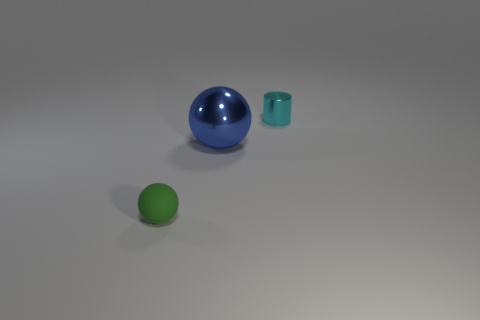Is there any other thing that is the same size as the cyan thing?
Provide a succinct answer. Yes. There is a metal object in front of the tiny cyan shiny thing; is it the same shape as the small metallic thing?
Ensure brevity in your answer.  No. Are there more tiny matte objects that are in front of the metallic cylinder than small blue rubber blocks?
Make the answer very short. Yes. What is the color of the thing that is in front of the ball that is behind the small ball?
Your response must be concise. Green. How many big green rubber things are there?
Provide a short and direct response. 0. What number of small things are both in front of the small cylinder and behind the green matte sphere?
Ensure brevity in your answer.  0. Are there any other things that have the same shape as the rubber thing?
Ensure brevity in your answer.  Yes. There is a small rubber thing; is its color the same as the metallic thing in front of the tiny metal cylinder?
Make the answer very short. No. There is a metal object that is in front of the cyan object; what is its shape?
Offer a terse response. Sphere. What number of other things are there of the same material as the tiny sphere
Keep it short and to the point. 0. 